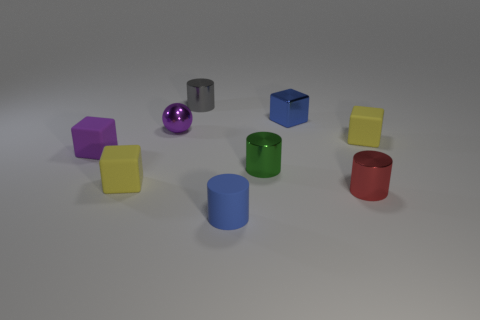Subtract 1 cylinders. How many cylinders are left? 3 Subtract all cylinders. How many objects are left? 5 Subtract 1 gray cylinders. How many objects are left? 8 Subtract all big metal balls. Subtract all blue rubber things. How many objects are left? 8 Add 5 small red metallic things. How many small red metallic things are left? 6 Add 2 yellow matte blocks. How many yellow matte blocks exist? 4 